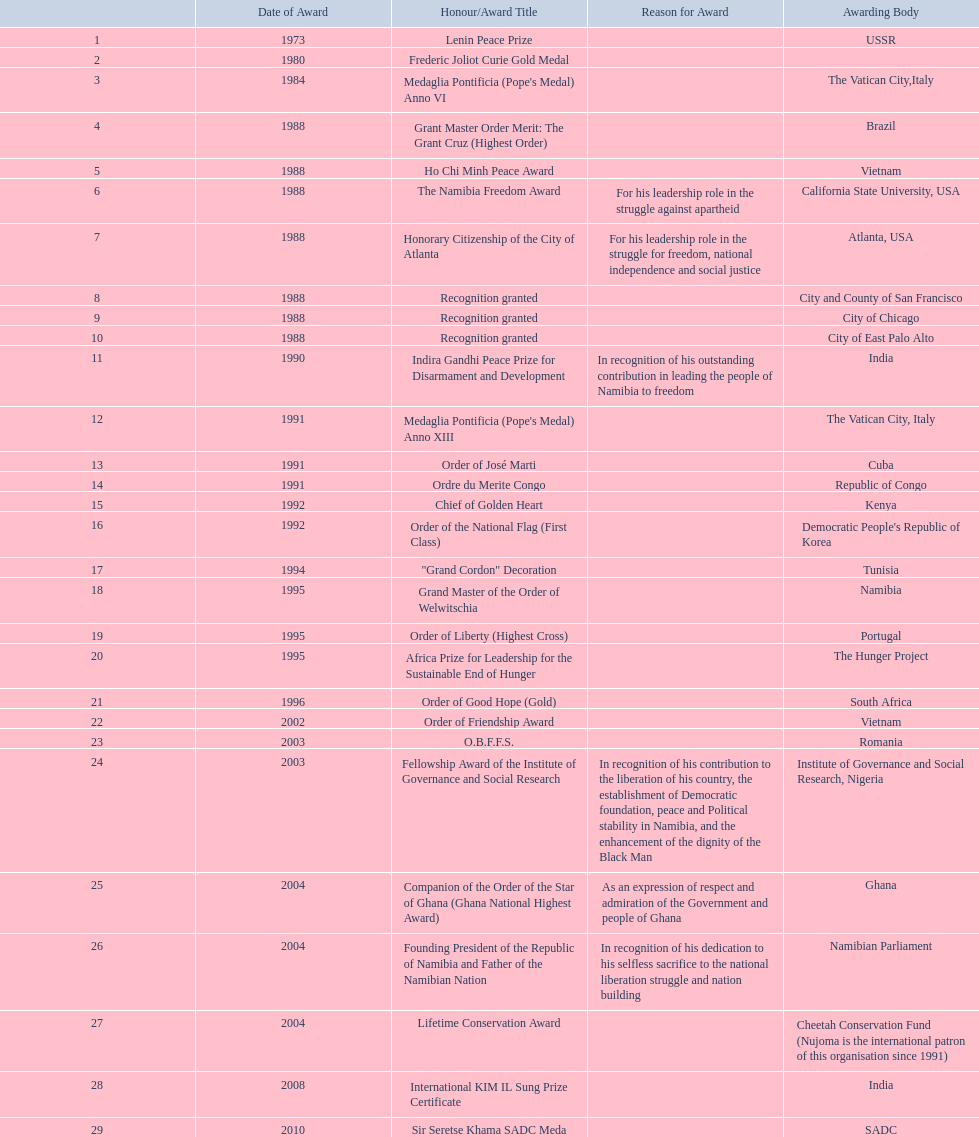What honors has sam nujoma received? 1, 1973, Lenin Peace Prize, Frederic Joliot Curie Gold Medal, Medaglia Pontificia (Pope's Medal) Anno VI, Grant Master Order Merit: The Grant Cruz (Highest Order), Ho Chi Minh Peace Award, The Namibia Freedom Award, Honorary Citizenship of the City of Atlanta, Recognition granted, Recognition granted, Recognition granted, Indira Gandhi Peace Prize for Disarmament and Development, Medaglia Pontificia (Pope's Medal) Anno XIII, Order of José Marti, Ordre du Merite Congo, Chief of Golden Heart, Order of the National Flag (First Class), "Grand Cordon" Decoration, Grand Master of the Order of Welwitschia, Order of Liberty (Highest Cross), Africa Prize for Leadership for the Sustainable End of Hunger, Order of Good Hope (Gold), Order of Friendship Award, O.B.F.F.S., Fellowship Award of the Institute of Governance and Social Research, Companion of the Order of the Star of Ghana (Ghana National Highest Award), Founding President of the Republic of Namibia and Father of the Namibian Nation, Lifetime Conservation Award, International KIM IL Sung Prize Certificate, Sir Seretse Khama SADC Meda. Who presented the obffs award? Romania. 